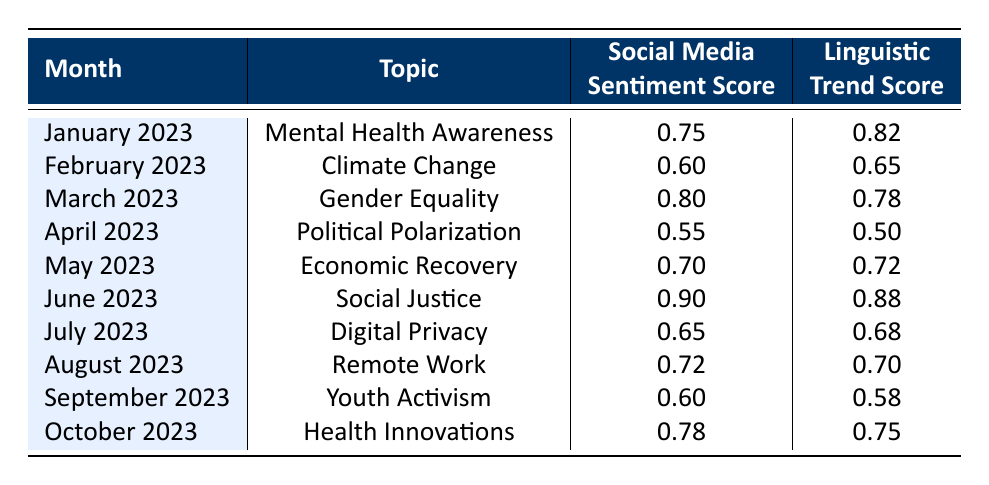What was the highest social media sentiment score recorded in the table? Scanning through the "Social Media Sentiment Score" column, the highest value is 0.90, which occurs in June 2023 under the topic "Social Justice."
Answer: 0.90 Which topic had the lowest linguistic trend score? Looking at the "Linguistic Trend Score" column, the lowest score is 0.50, which corresponds to "Political Polarization" in April 2023.
Answer: Political Polarization What is the average social media sentiment score across all months presented? To find the average, sum all the social media sentiment scores: 0.75 + 0.60 + 0.80 + 0.55 + 0.70 + 0.90 + 0.65 + 0.72 + 0.60 + 0.78 = 7.10. Then, divide by 10 (the number of months): 7.10 / 10 = 0.71.
Answer: 0.71 Is the linguistic trend score higher for "Youth Activism" than for "Digital Privacy"? The linguistic trend score for "Youth Activism" (0.58) is indeed lower than that for "Digital Privacy" (0.68), which confirms that the statement is true.
Answer: No In which month did the social media sentiment score and linguistic trend score both exceed 0.80? By checking the table, both scores exceed 0.80 in June 2023 for the topic "Social Justice," where the sentiment score is 0.90 and the linguistic trend score is 0.88.
Answer: June 2023 What is the difference in the linguistic trend scores between the highest and lowest scoring topics? The highest linguistic trend score is 0.88 (Social Justice) and the lowest is 0.50 (Political Polarization). The difference is calculated as 0.88 - 0.50 = 0.38.
Answer: 0.38 Which month had a social media sentiment score of 0.60? January 2023 has a sentiment score of 0.75, February 2023 has 0.60, while the other months have different scores. Thus, February 2023 is correct.
Answer: February 2023 Was the linguistic trend score for "Gender Equality" higher than that for "Health Innovations"? Checking the respective scores, "Gender Equality" has a score of 0.78, and "Health Innovations" has a score of 0.75. Therefore, the statement is true.
Answer: Yes 